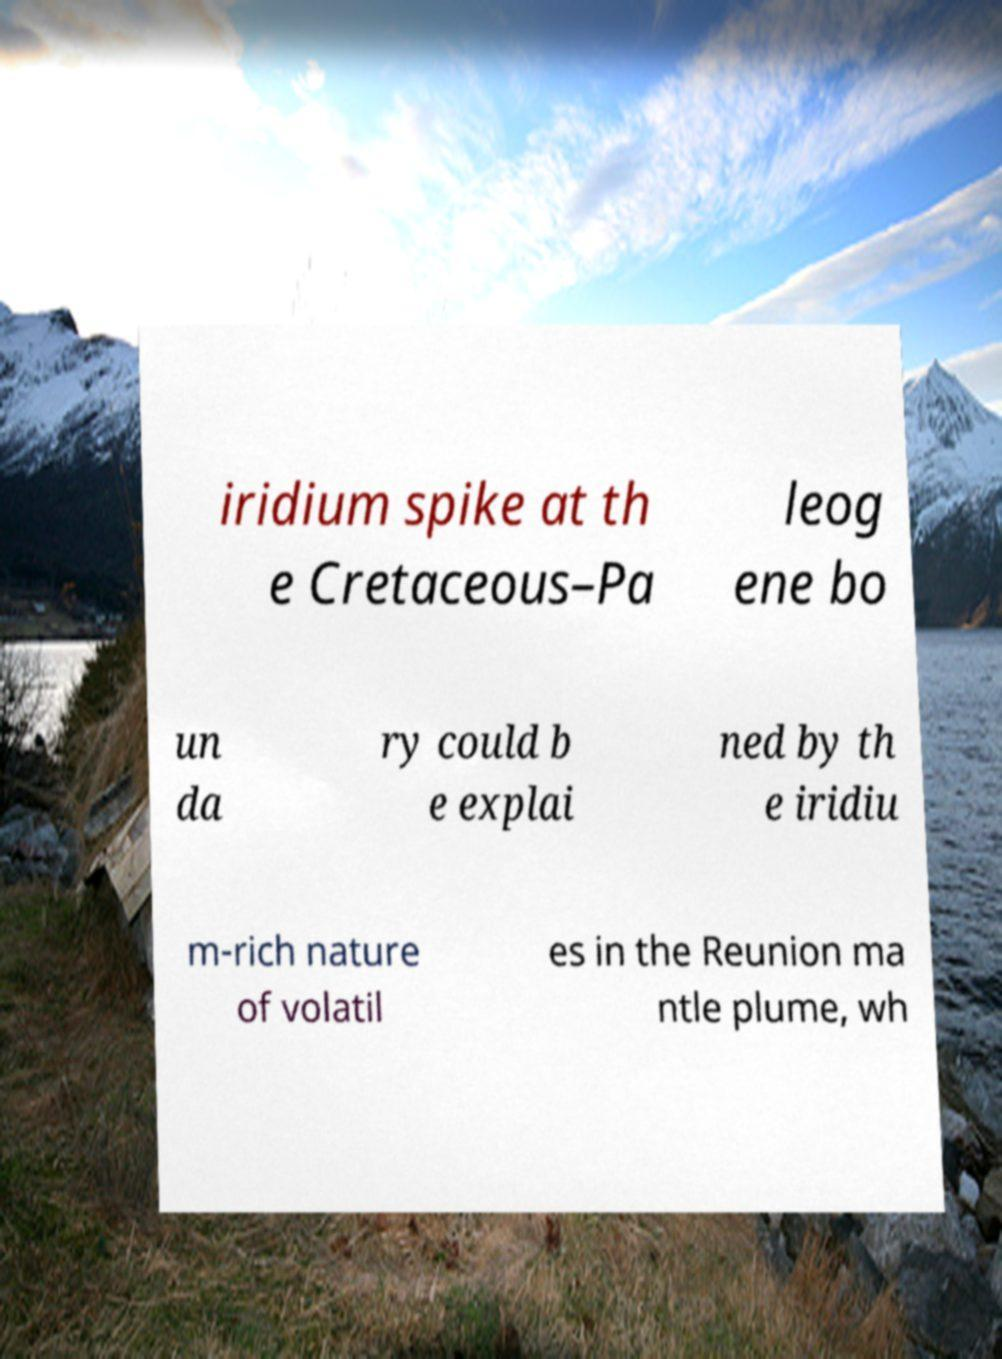Can you accurately transcribe the text from the provided image for me? iridium spike at th e Cretaceous–Pa leog ene bo un da ry could b e explai ned by th e iridiu m-rich nature of volatil es in the Reunion ma ntle plume, wh 